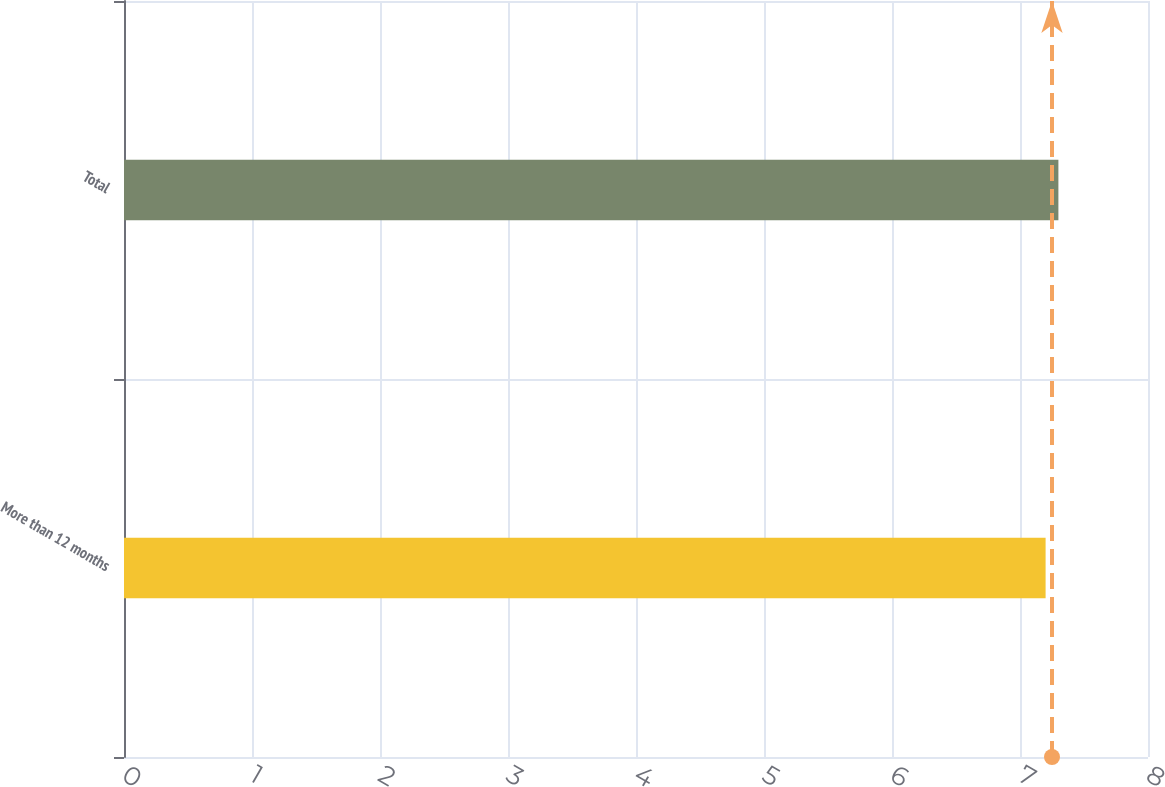<chart> <loc_0><loc_0><loc_500><loc_500><bar_chart><fcel>More than 12 months<fcel>Total<nl><fcel>7.2<fcel>7.3<nl></chart> 